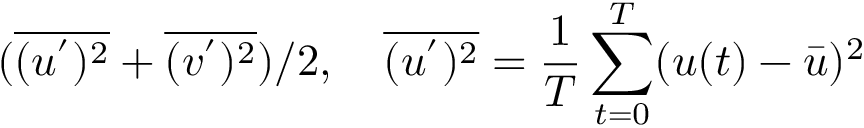<formula> <loc_0><loc_0><loc_500><loc_500>( \overline { { ( u ^ { ^ { \prime } } ) ^ { 2 } } } + \overline { { ( v ^ { ^ { \prime } } ) ^ { 2 } } } ) / 2 , \quad \overline { { ( u ^ { ^ { \prime } } ) ^ { 2 } } } = \frac { 1 } { T } \sum _ { t = 0 } ^ { T } ( u ( t ) - \bar { u } ) ^ { 2 }</formula> 